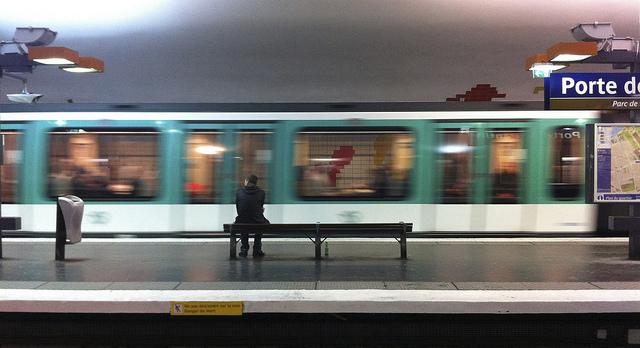What is the most likely location of this station? europe 